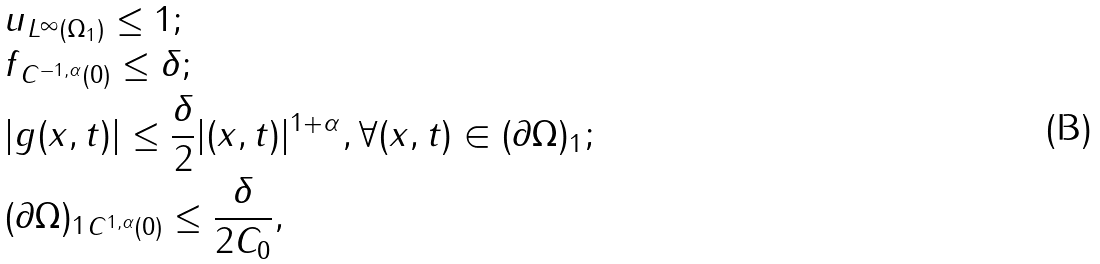Convert formula to latex. <formula><loc_0><loc_0><loc_500><loc_500>& \| u \| _ { L ^ { \infty } ( \Omega _ { 1 } ) } \leq 1 ; \\ & \| f \| _ { C ^ { - 1 , \alpha } ( 0 ) } \leq \delta ; \\ & | g ( x , t ) | \leq \frac { \delta } { 2 } | ( x , t ) | ^ { 1 + \alpha } , \forall ( x , t ) \in ( \partial \Omega ) _ { 1 } ; \\ & \| ( \partial \Omega ) _ { 1 } \| _ { C ^ { 1 , \alpha } ( 0 ) } \leq \frac { \delta } { 2 C _ { 0 } } ,</formula> 